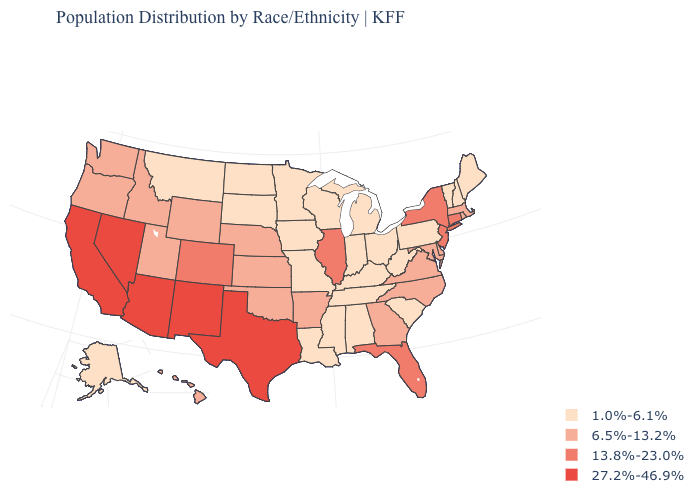Which states have the lowest value in the USA?
Write a very short answer. Alabama, Alaska, Indiana, Iowa, Kentucky, Louisiana, Maine, Michigan, Minnesota, Mississippi, Missouri, Montana, New Hampshire, North Dakota, Ohio, Pennsylvania, South Carolina, South Dakota, Tennessee, Vermont, West Virginia, Wisconsin. What is the value of Pennsylvania?
Quick response, please. 1.0%-6.1%. What is the value of California?
Give a very brief answer. 27.2%-46.9%. What is the lowest value in states that border Arkansas?
Be succinct. 1.0%-6.1%. Name the states that have a value in the range 6.5%-13.2%?
Be succinct. Arkansas, Delaware, Georgia, Hawaii, Idaho, Kansas, Maryland, Massachusetts, Nebraska, North Carolina, Oklahoma, Oregon, Rhode Island, Utah, Virginia, Washington, Wyoming. What is the value of Arizona?
Be succinct. 27.2%-46.9%. Name the states that have a value in the range 27.2%-46.9%?
Write a very short answer. Arizona, California, Nevada, New Mexico, Texas. Among the states that border West Virginia , does Ohio have the highest value?
Give a very brief answer. No. Does Nebraska have a higher value than Delaware?
Write a very short answer. No. Does the map have missing data?
Answer briefly. No. Which states hav the highest value in the West?
Answer briefly. Arizona, California, Nevada, New Mexico. What is the value of South Dakota?
Short answer required. 1.0%-6.1%. What is the highest value in the South ?
Quick response, please. 27.2%-46.9%. Name the states that have a value in the range 27.2%-46.9%?
Short answer required. Arizona, California, Nevada, New Mexico, Texas. Does Arkansas have a lower value than New Jersey?
Short answer required. Yes. 